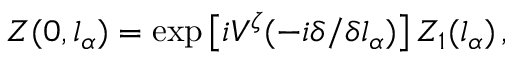Convert formula to latex. <formula><loc_0><loc_0><loc_500><loc_500>Z ( 0 , l _ { \alpha } ) = \exp \left [ i V ^ { \zeta } ( - i \delta / \delta l _ { \alpha } ) \right ] Z _ { 1 } ( l _ { \alpha } ) \, ,</formula> 